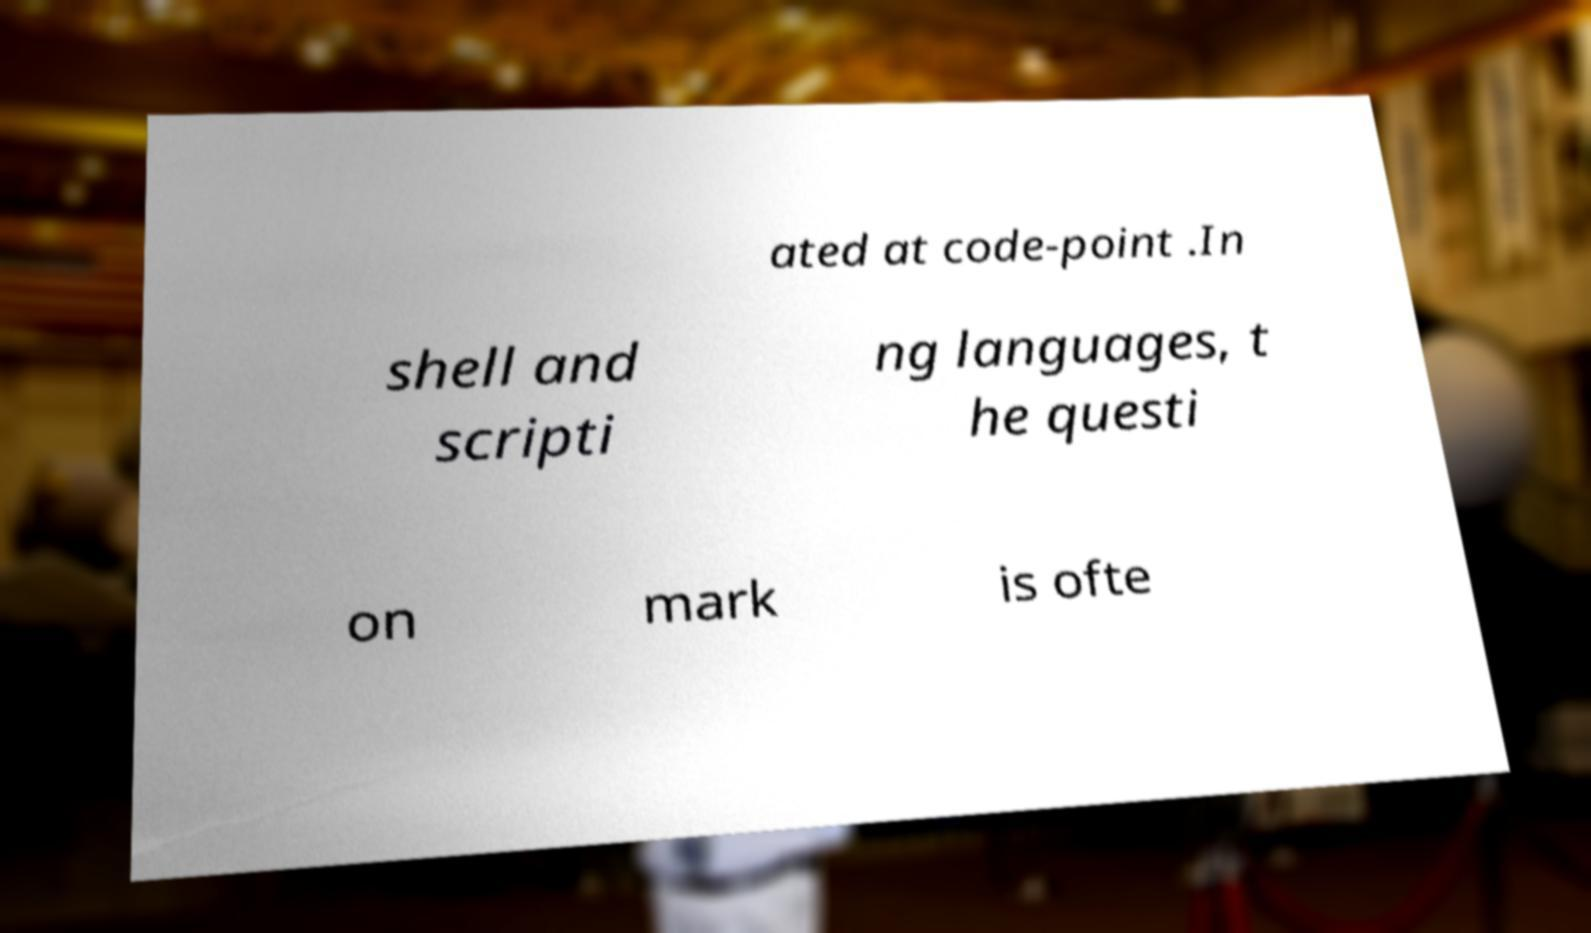What messages or text are displayed in this image? I need them in a readable, typed format. ated at code-point .In shell and scripti ng languages, t he questi on mark is ofte 